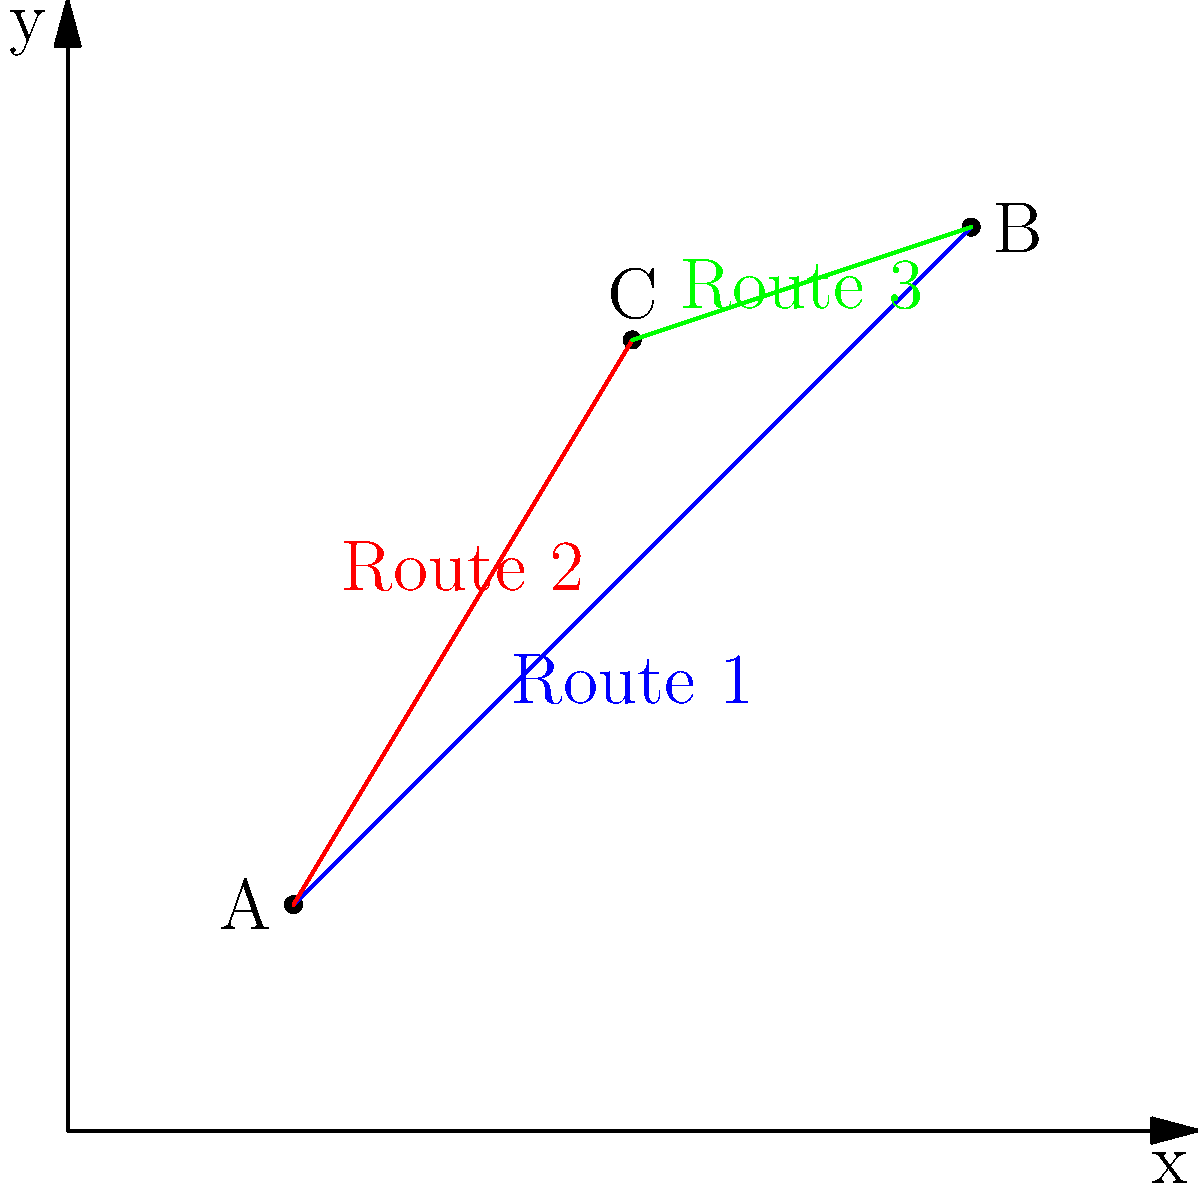As a criminology professor researching innovative approaches to public safety, you are tasked with analyzing emergency response routes in a city. Given the vector representation of three routes between key locations A(2,2), B(8,8), and C(5,7), determine which route would be the most efficient for emergency vehicles to take. Calculate the magnitudes of the vectors representing each route and rank them from shortest to longest.

Route 1: $\vec{AB}$
Route 2: $\vec{AC}$
Route 3: $\vec{BC}$

Provide the ranking of routes from most efficient (shortest) to least efficient (longest). To solve this problem, we need to calculate the magnitude of each vector representing the routes and then rank them from shortest to longest.

Step 1: Calculate the components of each vector.
$\vec{AB} = (8-2, 8-2) = (6, 6)$
$\vec{AC} = (5-2, 7-2) = (3, 5)$
$\vec{BC} = (5-8, 7-8) = (-3, -1)$

Step 2: Calculate the magnitude of each vector using the formula $\sqrt{x^2 + y^2}$.

For $\vec{AB}$:
$|\vec{AB}| = \sqrt{6^2 + 6^2} = \sqrt{72} = 6\sqrt{2} \approx 8.49$

For $\vec{AC}$:
$|\vec{AC}| = \sqrt{3^2 + 5^2} = \sqrt{34} \approx 5.83$

For $\vec{BC}$:
$|\vec{BC}| = \sqrt{(-3)^2 + (-1)^2} = \sqrt{10} \approx 3.16$

Step 3: Rank the routes from shortest to longest.

1. Route 3 ($\vec{BC}$): $\sqrt{10} \approx 3.16$
2. Route 2 ($\vec{AC}$): $\sqrt{34} \approx 5.83$
3. Route 1 ($\vec{AB}$): $6\sqrt{2} \approx 8.49$

Therefore, the ranking from most efficient (shortest) to least efficient (longest) is: Route 3, Route 2, Route 1.
Answer: Route 3, Route 2, Route 1 